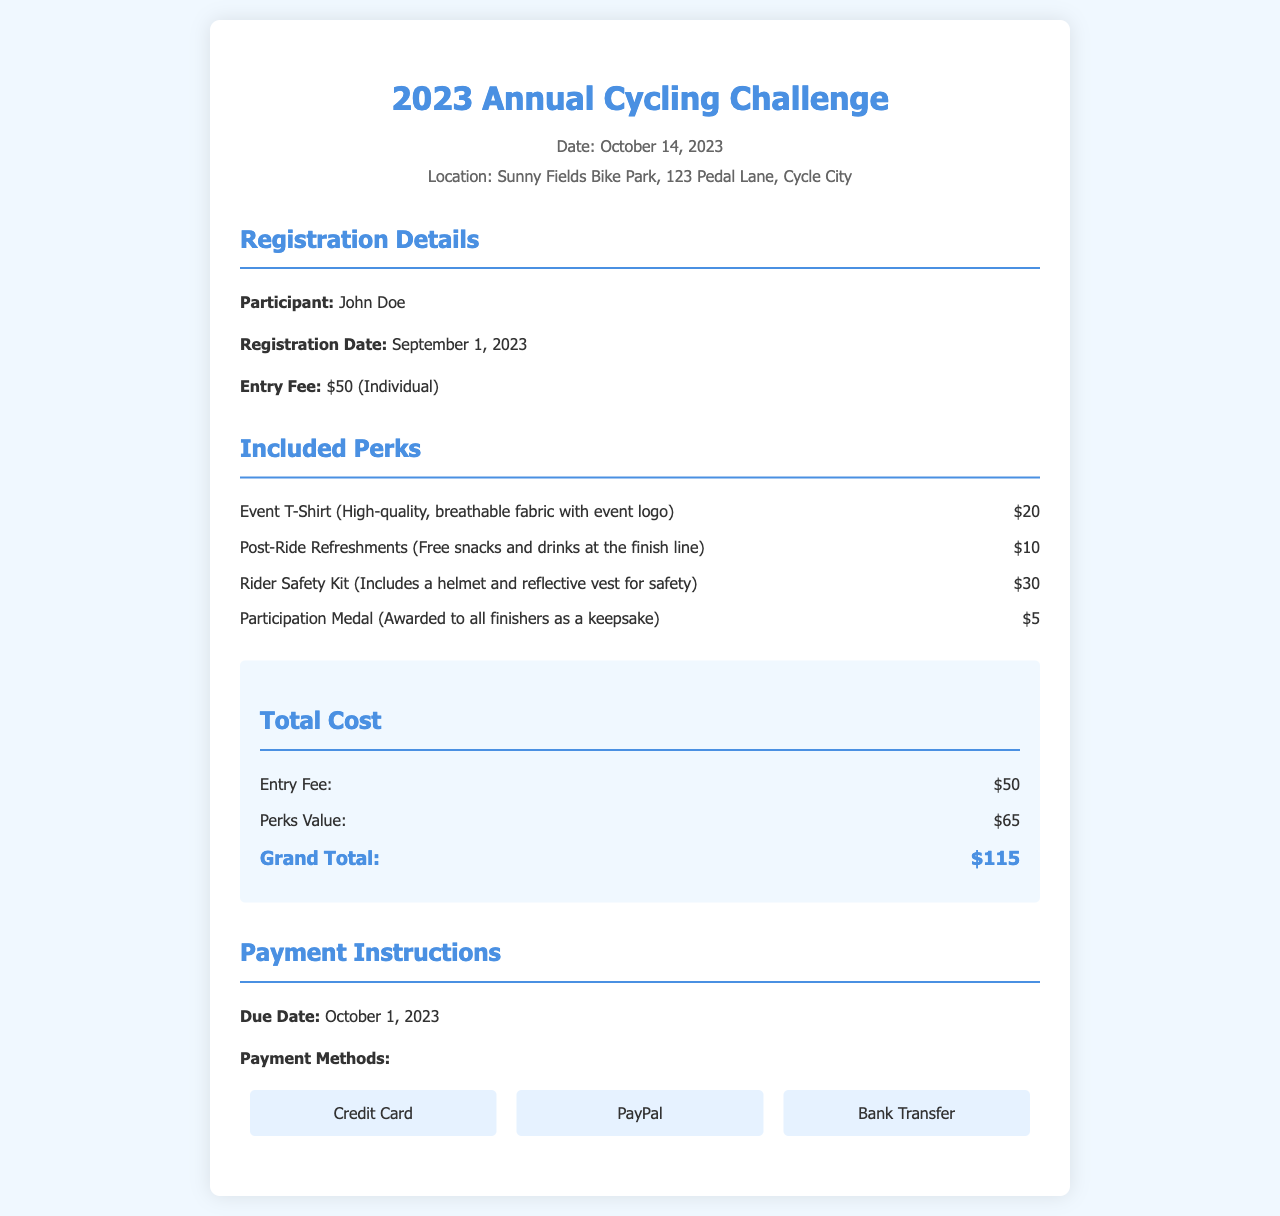What is the date of the event? The event date is mentioned at the top of the invoice.
Answer: October 14, 2023 What is the entry fee for the cycling event? The entry fee is listed under the registration details section.
Answer: $50 (Individual) Who is the participant named in the invoice? The participant's name is indicated in the registration details.
Answer: John Doe What is the total cost mentioned in the invoice? The total cost is stated in the total cost section as the grand total.
Answer: $115 What perks are included in the registration fee? The invoice lists multiple perks under the included perks section.
Answer: Event T-Shirt, Post-Ride Refreshments, Rider Safety Kit, Participation Medal What is the due date for payment? The due date is specified in the payment instructions section.
Answer: October 1, 2023 Which payment methods are available? Payment methods are listed in the payment instructions section of the document.
Answer: Credit Card, PayPal, Bank Transfer What is the value of the perks included? The total value of the perks is calculated and provided in the total cost section.
Answer: $65 What location is the event being held at? The location is provided at the top of the invoice along with the date.
Answer: Sunny Fields Bike Park, 123 Pedal Lane, Cycle City 